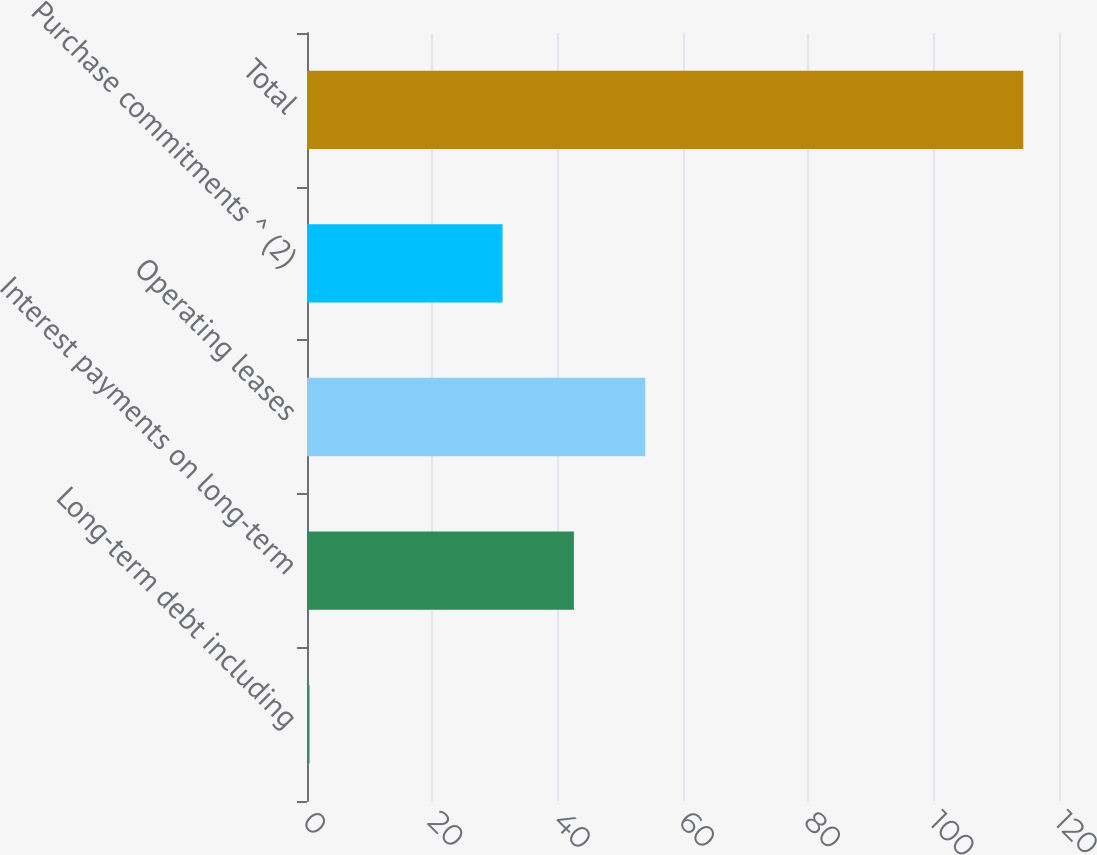<chart> <loc_0><loc_0><loc_500><loc_500><bar_chart><fcel>Long-term debt including<fcel>Interest payments on long-term<fcel>Operating leases<fcel>Purchase commitments ^ (2)<fcel>Total<nl><fcel>0.4<fcel>42.59<fcel>53.98<fcel>31.2<fcel>114.3<nl></chart> 